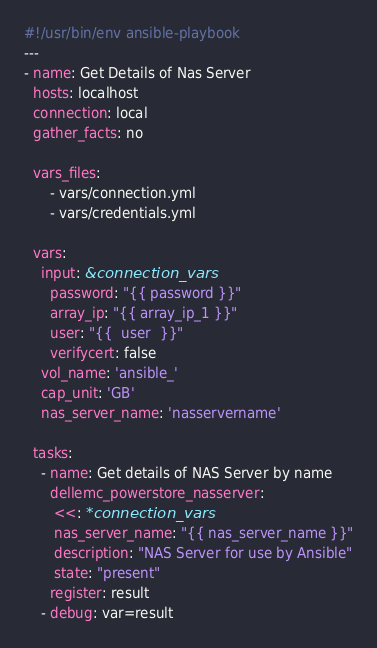Convert code to text. <code><loc_0><loc_0><loc_500><loc_500><_YAML_>#!/usr/bin/env ansible-playbook
---
- name: Get Details of Nas Server
  hosts: localhost
  connection: local
  gather_facts: no

  vars_files:
      - vars/connection.yml
      - vars/credentials.yml

  vars:
    input: &connection_vars
      password: "{{ password }}"
      array_ip: "{{ array_ip_1 }}"
      user: "{{  user  }}"
      verifycert: false
    vol_name: 'ansible_'
    cap_unit: 'GB'
    nas_server_name: 'nasservername'

  tasks:
    - name: Get details of NAS Server by name
      dellemc_powerstore_nasserver:
       <<: *connection_vars
       nas_server_name: "{{ nas_server_name }}"
       description: "NAS Server for use by Ansible"
       state: "present"
      register: result
    - debug: var=result
</code> 